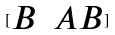Convert formula to latex. <formula><loc_0><loc_0><loc_500><loc_500>[ \begin{matrix} B & A B \end{matrix} ]</formula> 